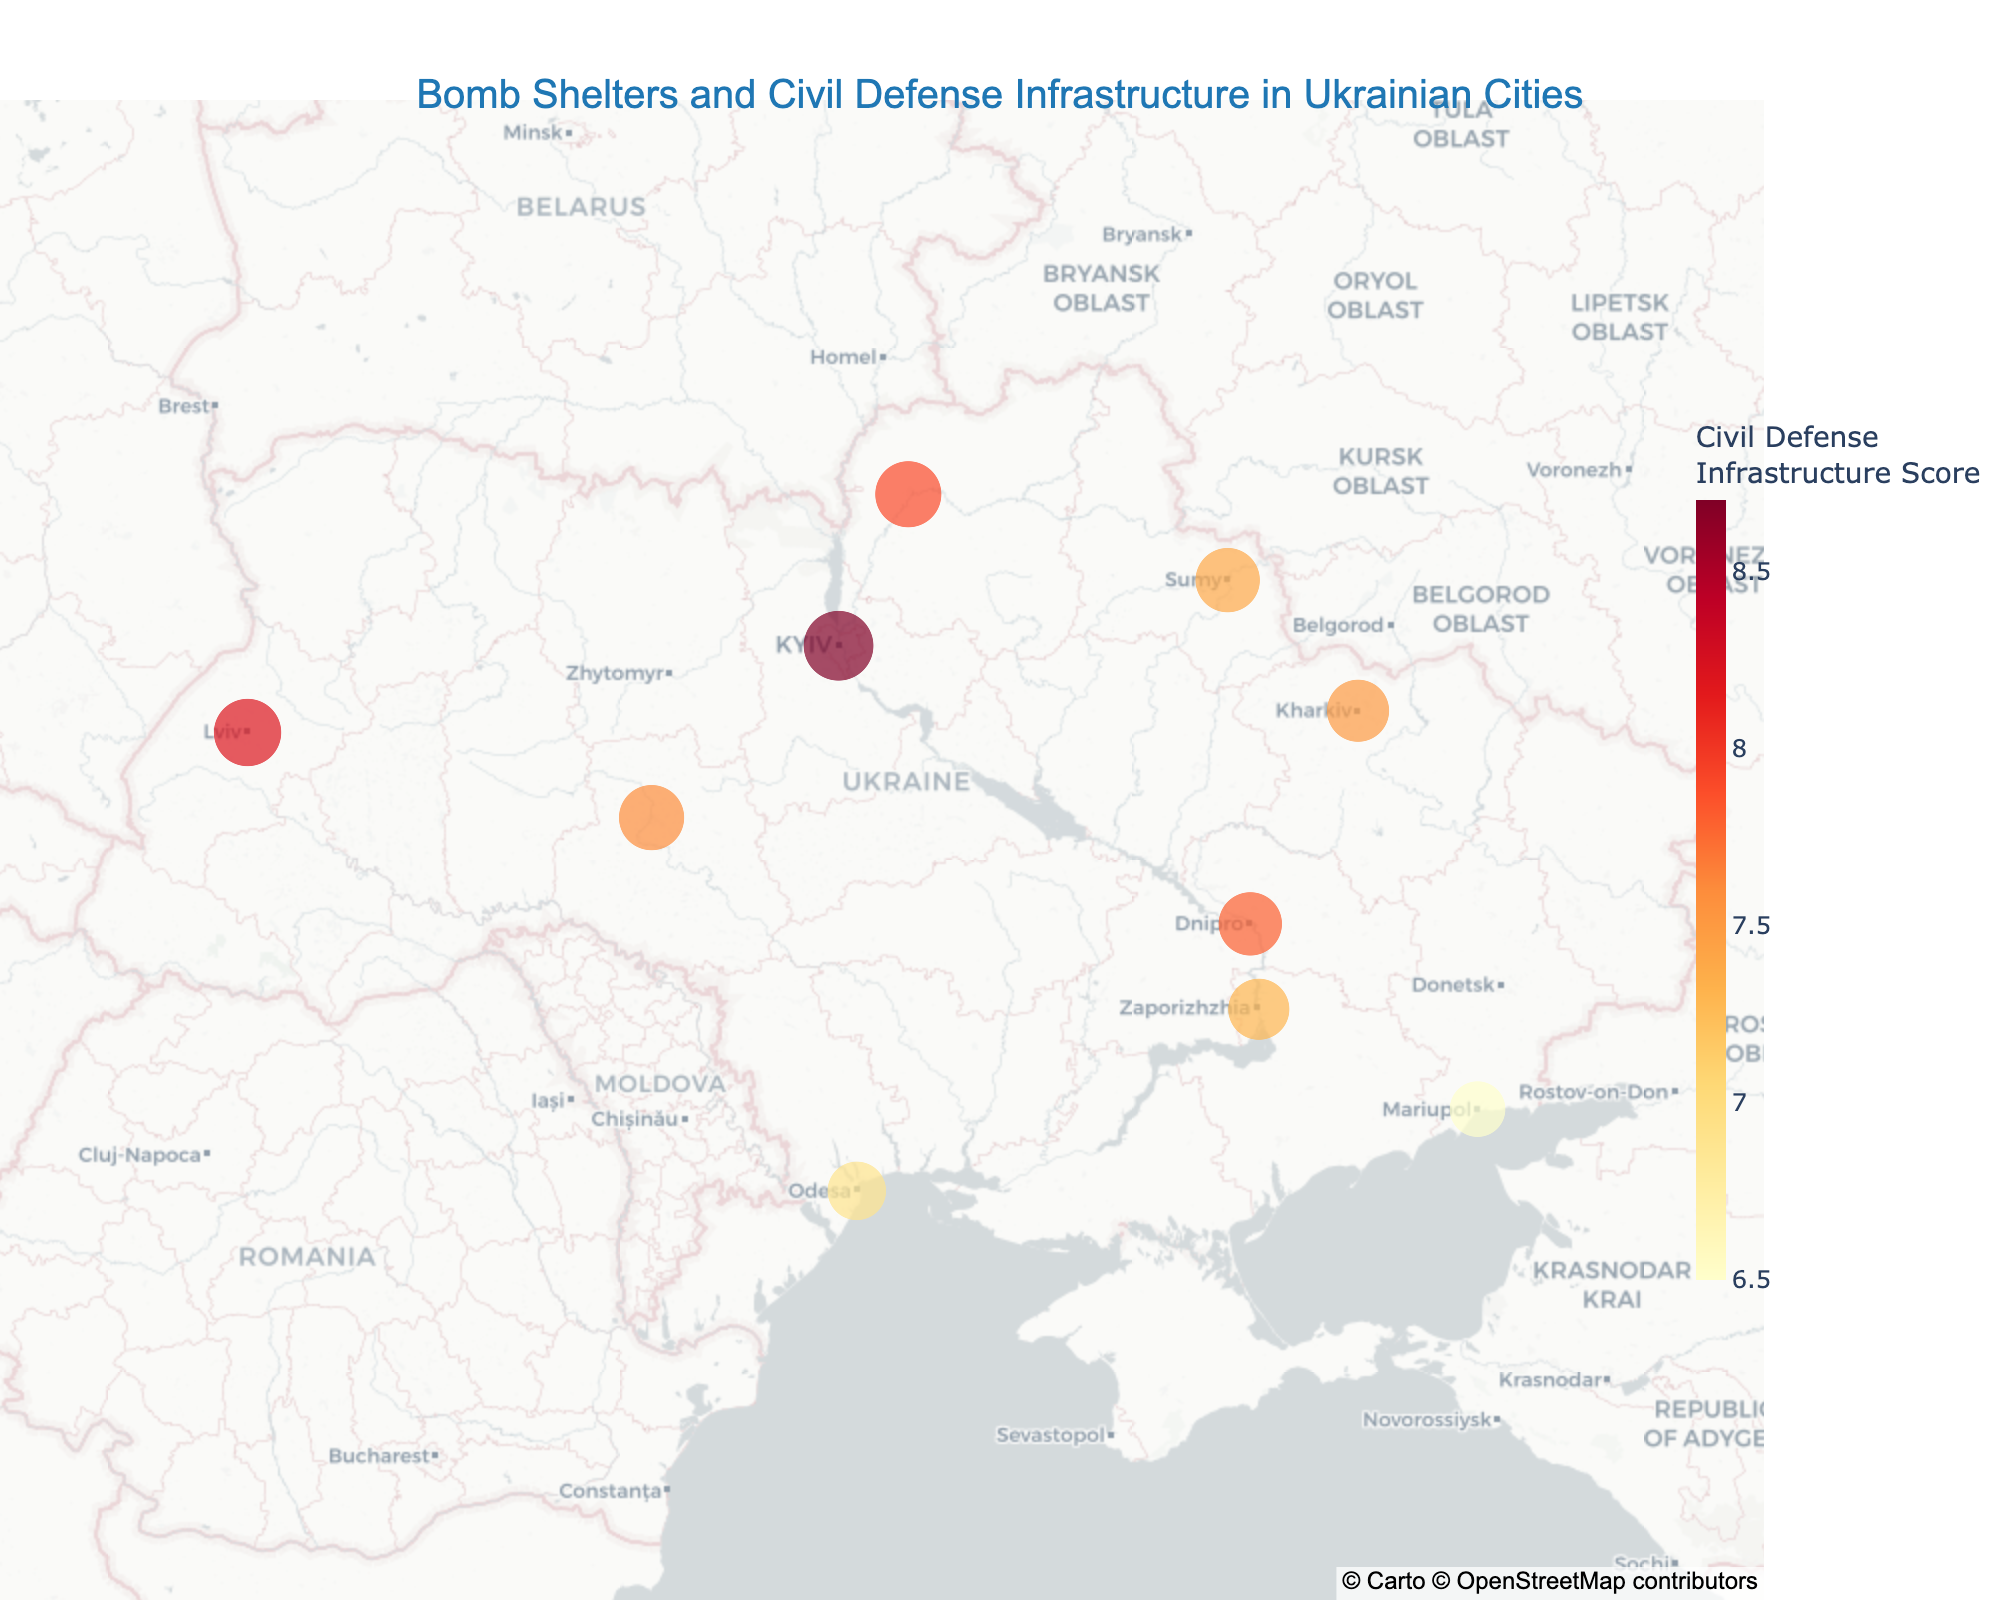Which city has the highest number of bomb shelters per 10k people? Look for the largest size marker on the map which represents the city with the most bomb shelters per 10k people. Kyiv has the largest marker size.
Answer: Kyiv Which city scores the highest in civil defense infrastructure? Observe the color intensity on the map. The darkest color represents the highest civil defense infrastructure score. Kyiv has the darkest color.
Answer: Kyiv Compare the bomb shelters per 10k people of Odesa and Lviv. Which city has more? Look at the size of the markers for Odesa and Lviv. Lviv has a larger marker size than Odesa.
Answer: Lviv Which city has both a high number of bomb shelters and a high civil defense infrastructure score? Find the city with a large marker size and dark color to identify both high values. Kyiv meets these criteria.
Answer: Kyiv What is the title of the figure? Read the text at the top of the figure, which provides the title. The title is "Bomb Shelters and Civil Defense Infrastructure in Ukrainian Cities".
Answer: Bomb Shelters and Civil Defense Infrastructure in Ukrainian Cities Identify a city with a lower number of bomb shelters but a higher civil defense score compared to Mariupol. Look for cities with smaller markers but darker colors compared to Mariupol. Chernihiv has fewer bomb shelters but a higher civil defense score.
Answer: Chernihiv What is the civil defense infrastructure score for Sumy? Hover over the marker for Sumy to see the details in the hover box. The score for Sumy is 7.4.
Answer: 7.4 What is the latitude and longitude of Kharkiv? Hover over the marker for Kharkiv to see the coordinates in the hover box. The coordinates are 49.9935, 36.2304.
Answer: 49.9935, 36.2304 What is the average civil defense infrastructure score for Kyiv, Lviv, and Odesa? Add the civil defense scores for Kyiv (8.7), Lviv (8.2), and Odesa (6.9), then divide by 3. The average is (8.7 + 8.2 + 6.9) / 3 = 7.93.
Answer: 7.93 